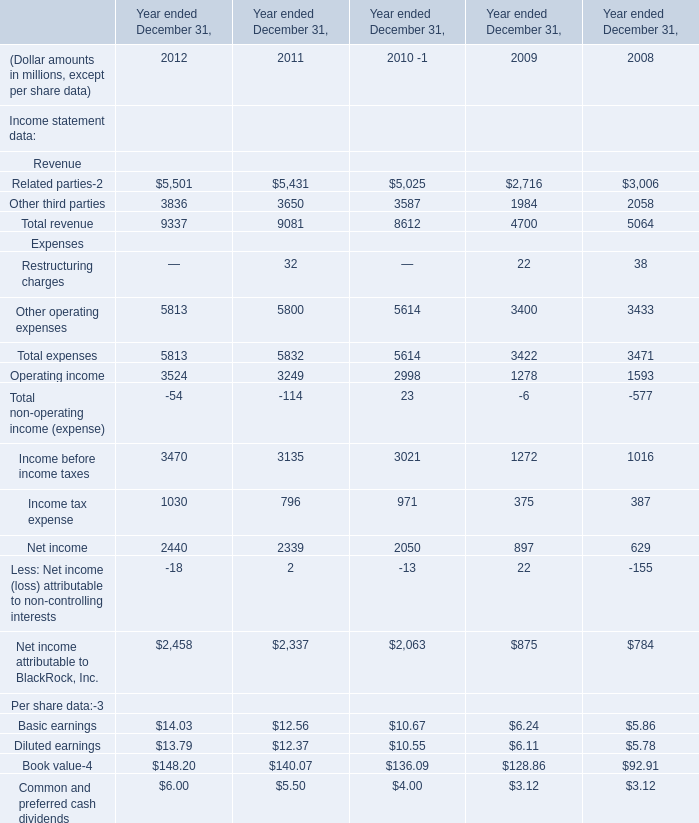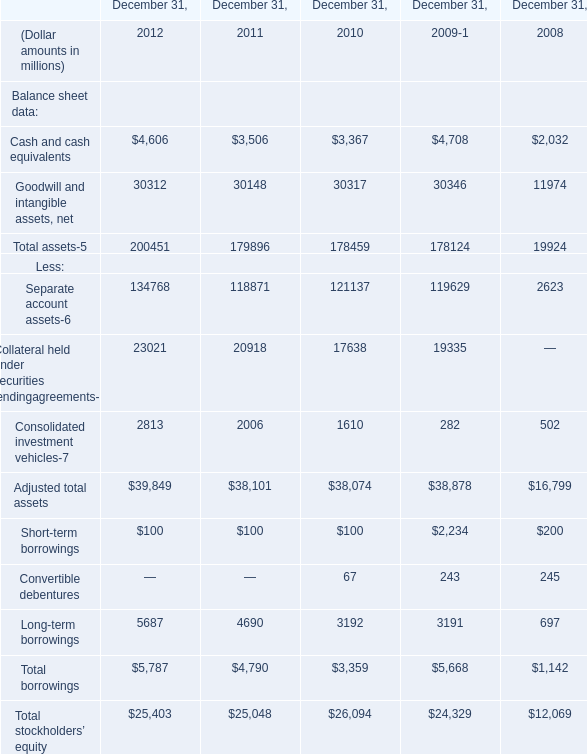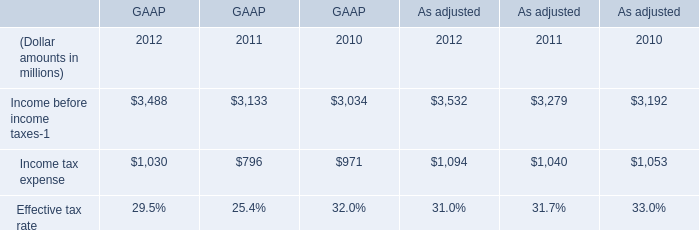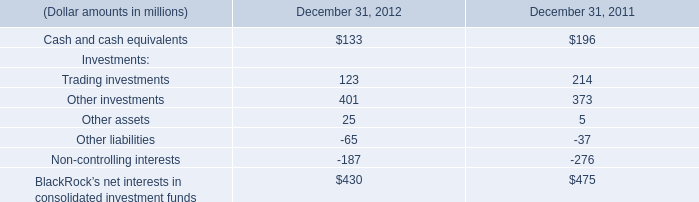what is the total of the company 2019s future minimum revenues under the terms of all non-cancelable tenant sublease from 2009-2011 , in millions?\\n 
Computations: ((5.6 + 5.4) + 4.5)
Answer: 15.5. 